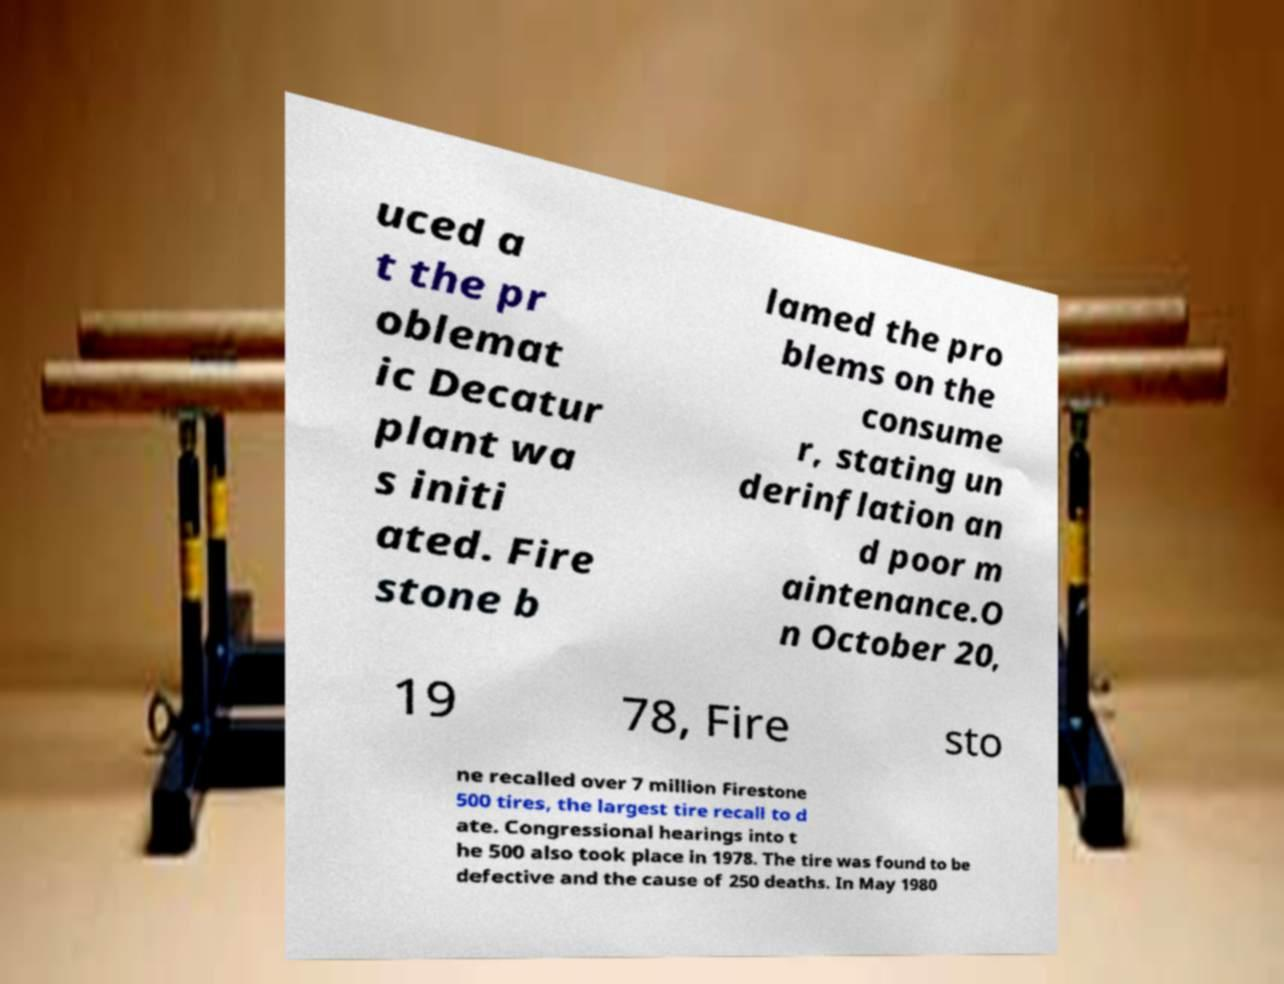There's text embedded in this image that I need extracted. Can you transcribe it verbatim? uced a t the pr oblemat ic Decatur plant wa s initi ated. Fire stone b lamed the pro blems on the consume r, stating un derinflation an d poor m aintenance.O n October 20, 19 78, Fire sto ne recalled over 7 million Firestone 500 tires, the largest tire recall to d ate. Congressional hearings into t he 500 also took place in 1978. The tire was found to be defective and the cause of 250 deaths. In May 1980 